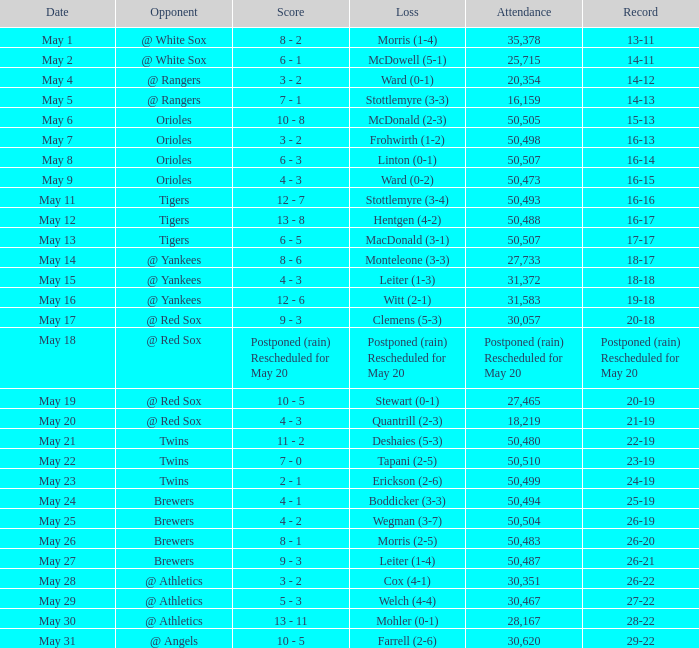To what team did they concede defeat with a 28-22 record? Mohler (0-1). 